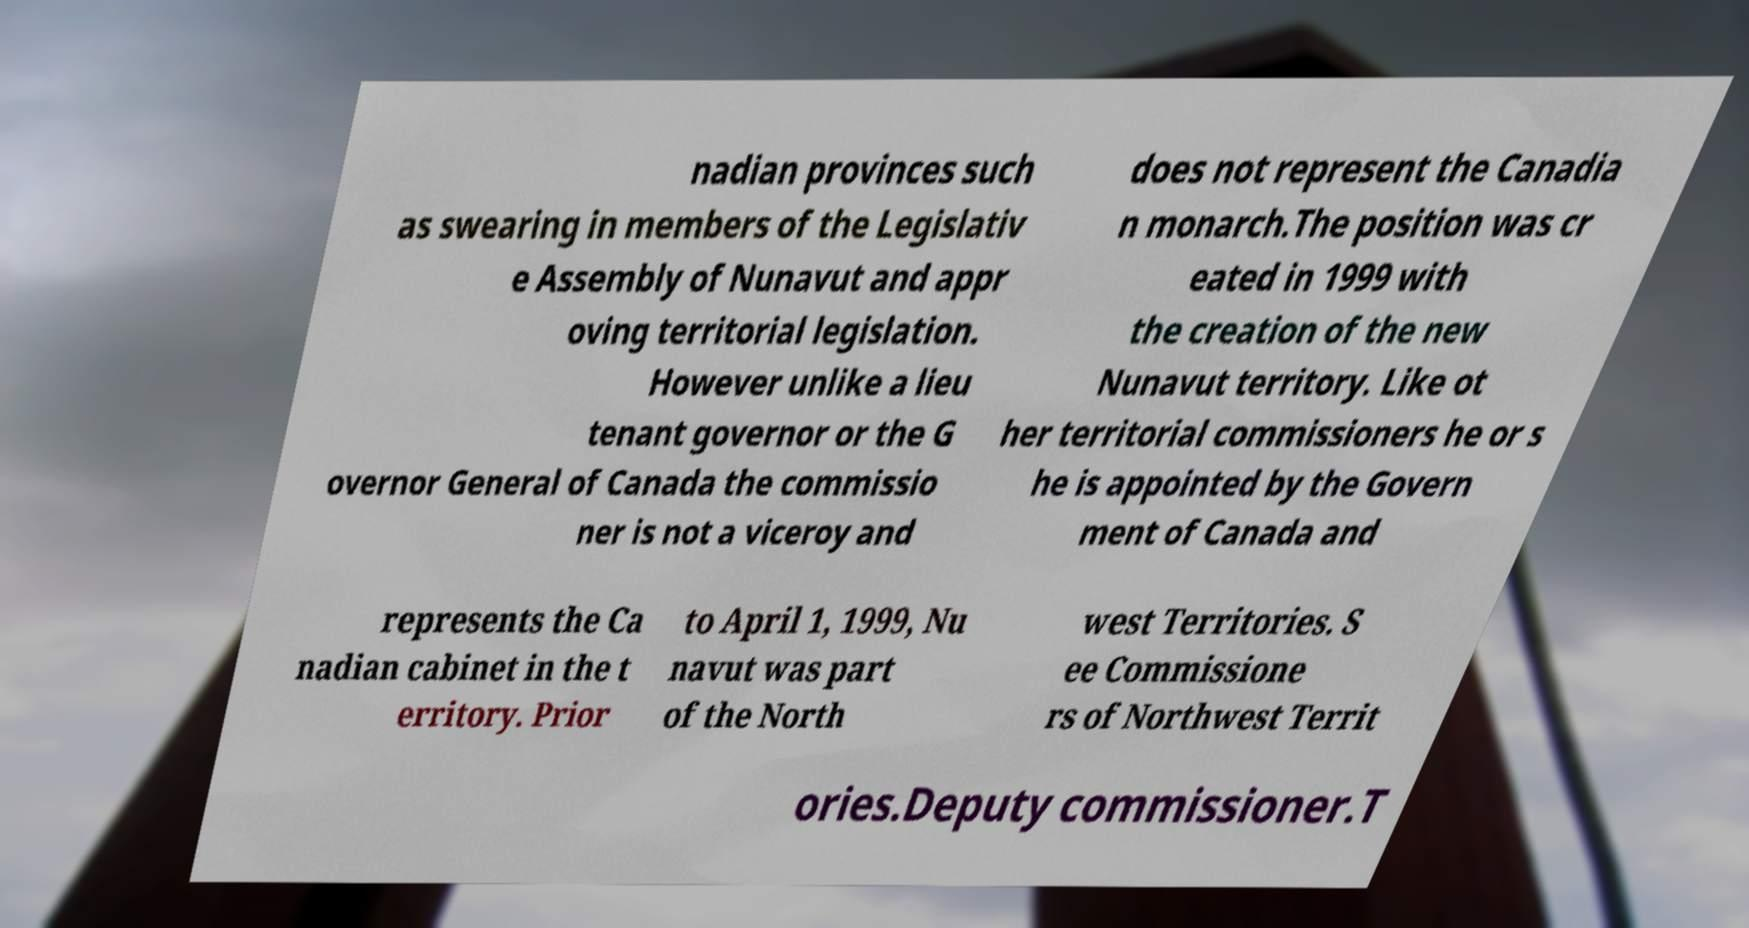Could you extract and type out the text from this image? nadian provinces such as swearing in members of the Legislativ e Assembly of Nunavut and appr oving territorial legislation. However unlike a lieu tenant governor or the G overnor General of Canada the commissio ner is not a viceroy and does not represent the Canadia n monarch.The position was cr eated in 1999 with the creation of the new Nunavut territory. Like ot her territorial commissioners he or s he is appointed by the Govern ment of Canada and represents the Ca nadian cabinet in the t erritory. Prior to April 1, 1999, Nu navut was part of the North west Territories. S ee Commissione rs of Northwest Territ ories.Deputy commissioner.T 